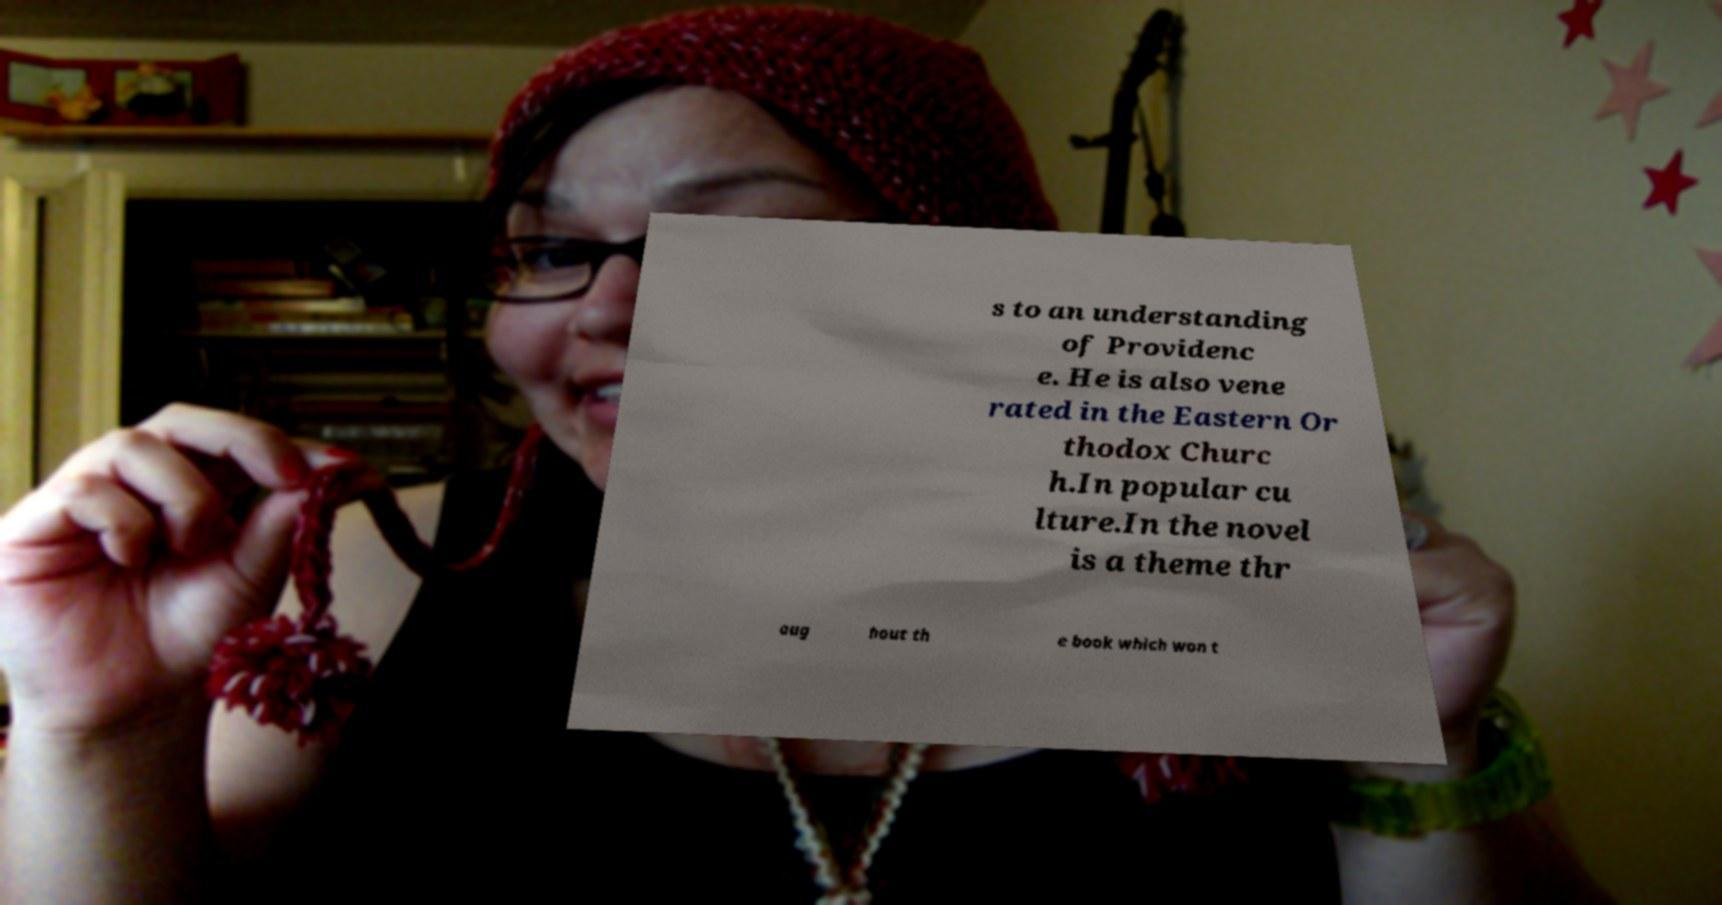For documentation purposes, I need the text within this image transcribed. Could you provide that? s to an understanding of Providenc e. He is also vene rated in the Eastern Or thodox Churc h.In popular cu lture.In the novel is a theme thr oug hout th e book which won t 